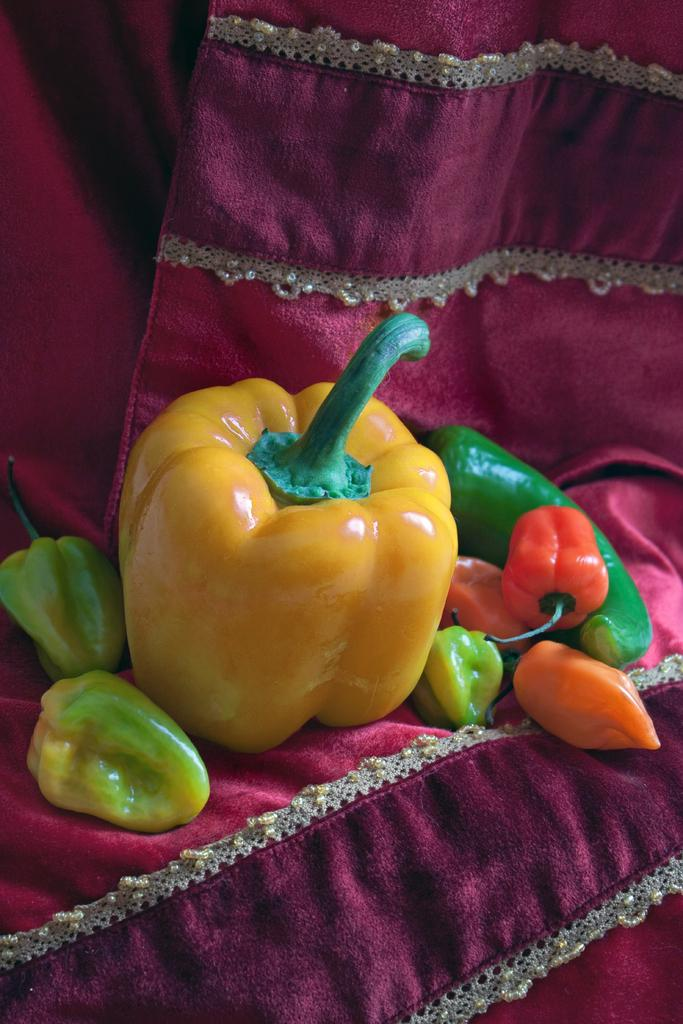What type of vegetables are present in the image? There are capsicum and chilies in the image. What is the color of the cloth on which the capsicum and chilies are placed? The capsicum and chilies are placed on a red colored cloth. How many dogs are visible in the image? There are no dogs present in the image. What type of base is supporting the capsicum and chilies in the image? The capsicum and chilies are not resting on a base; they are placed on a red colored cloth. 